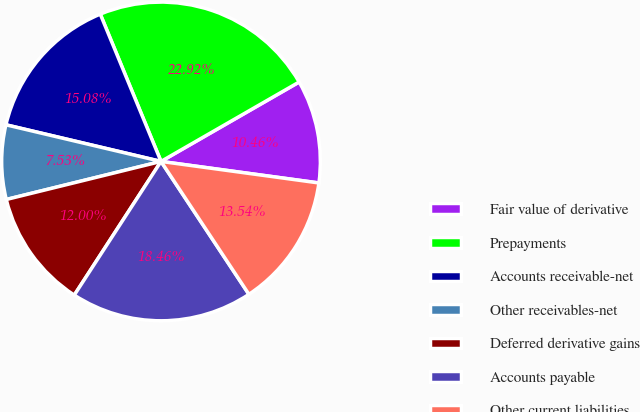<chart> <loc_0><loc_0><loc_500><loc_500><pie_chart><fcel>Fair value of derivative<fcel>Prepayments<fcel>Accounts receivable-net<fcel>Other receivables-net<fcel>Deferred derivative gains<fcel>Accounts payable<fcel>Other current liabilities<nl><fcel>10.46%<fcel>22.92%<fcel>15.08%<fcel>7.53%<fcel>12.0%<fcel>18.46%<fcel>13.54%<nl></chart> 